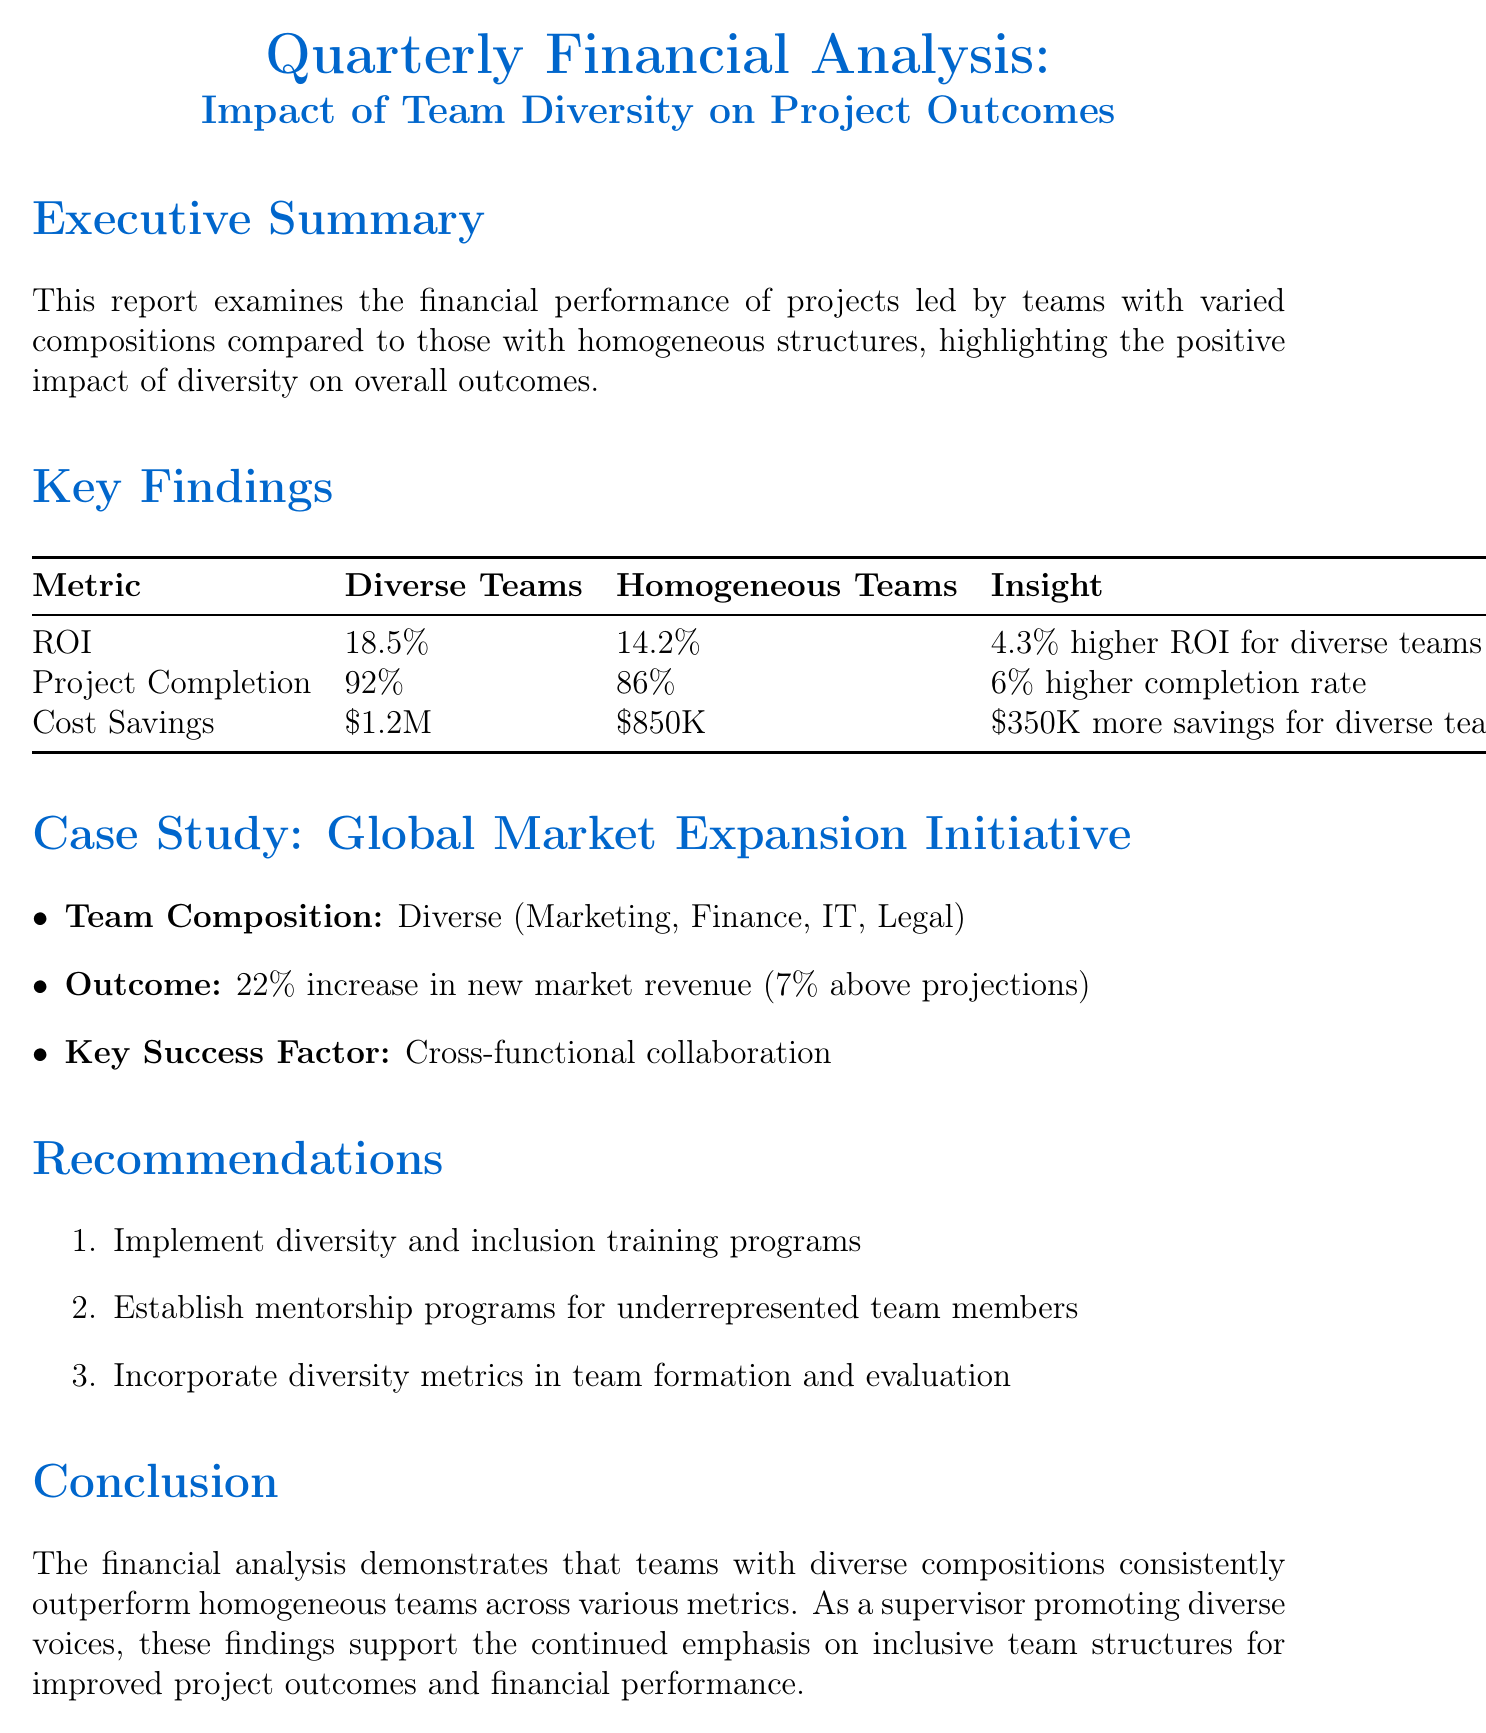What is the ROI for diverse teams? The ROI for diverse teams is provided in the key findings section of the report.
Answer: 18.5% What is the project completion rate for homogeneous teams? The project completion rate for homogeneous teams is detailed in the key findings section.
Answer: 86% How much cost savings did diverse teams achieve? The cost savings achieved by diverse teams is indicated in the financial metrics comparison.
Answer: $1.2M What was the increase in new market revenue for the Global Market Expansion Initiative? The document states that the increase in new market revenue is specified in the case study section.
Answer: 22% What is a key success factor mentioned in the case study? A key success factor for the project outcome is found in the summary of the case study.
Answer: Cross-functional collaboration How much higher is the ROI for diverse teams compared to homogeneous teams? The difference in ROI is highlighted in the key findings and requires comparing the two percentages.
Answer: 4.3% What recommendation is given for supporting underrepresented team members? One of the recommendations focuses on enhancing support systems for specific team demographics.
Answer: Establish mentorship programs What is the primary conclusion of the report? The conclusion summarizes the overall findings and implications regarding team diversity and performance.
Answer: Teams with diverse compositions consistently outperform homogeneous teams 